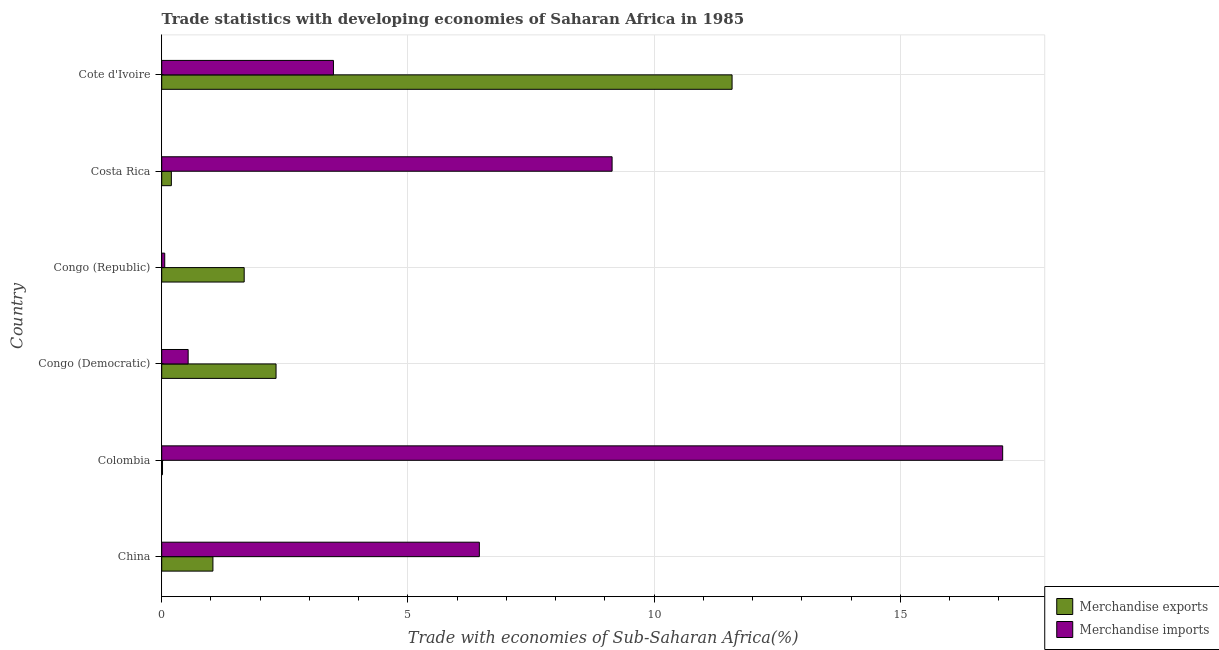What is the label of the 6th group of bars from the top?
Give a very brief answer. China. What is the merchandise imports in Cote d'Ivoire?
Offer a very short reply. 3.49. Across all countries, what is the maximum merchandise imports?
Ensure brevity in your answer.  17.08. Across all countries, what is the minimum merchandise imports?
Provide a short and direct response. 0.06. In which country was the merchandise exports maximum?
Give a very brief answer. Cote d'Ivoire. In which country was the merchandise imports minimum?
Keep it short and to the point. Congo (Republic). What is the total merchandise exports in the graph?
Your answer should be very brief. 16.83. What is the difference between the merchandise imports in China and that in Congo (Democratic)?
Your answer should be compact. 5.91. What is the difference between the merchandise imports in Colombia and the merchandise exports in Congo (Democratic)?
Ensure brevity in your answer.  14.76. What is the average merchandise exports per country?
Offer a very short reply. 2.81. What is the difference between the merchandise exports and merchandise imports in Colombia?
Your answer should be very brief. -17.06. What is the ratio of the merchandise imports in China to that in Colombia?
Your answer should be compact. 0.38. Is the merchandise exports in Congo (Democratic) less than that in Congo (Republic)?
Make the answer very short. No. What is the difference between the highest and the second highest merchandise exports?
Make the answer very short. 9.26. What is the difference between the highest and the lowest merchandise imports?
Your answer should be compact. 17.02. Is the sum of the merchandise exports in China and Congo (Republic) greater than the maximum merchandise imports across all countries?
Provide a succinct answer. No. What does the 2nd bar from the bottom in Colombia represents?
Keep it short and to the point. Merchandise imports. How many bars are there?
Your answer should be very brief. 12. Are the values on the major ticks of X-axis written in scientific E-notation?
Offer a very short reply. No. Does the graph contain any zero values?
Keep it short and to the point. No. Where does the legend appear in the graph?
Give a very brief answer. Bottom right. How are the legend labels stacked?
Offer a very short reply. Vertical. What is the title of the graph?
Make the answer very short. Trade statistics with developing economies of Saharan Africa in 1985. What is the label or title of the X-axis?
Keep it short and to the point. Trade with economies of Sub-Saharan Africa(%). What is the label or title of the Y-axis?
Make the answer very short. Country. What is the Trade with economies of Sub-Saharan Africa(%) in Merchandise exports in China?
Offer a very short reply. 1.04. What is the Trade with economies of Sub-Saharan Africa(%) of Merchandise imports in China?
Offer a very short reply. 6.45. What is the Trade with economies of Sub-Saharan Africa(%) in Merchandise exports in Colombia?
Keep it short and to the point. 0.02. What is the Trade with economies of Sub-Saharan Africa(%) of Merchandise imports in Colombia?
Offer a very short reply. 17.08. What is the Trade with economies of Sub-Saharan Africa(%) of Merchandise exports in Congo (Democratic)?
Your response must be concise. 2.32. What is the Trade with economies of Sub-Saharan Africa(%) of Merchandise imports in Congo (Democratic)?
Give a very brief answer. 0.54. What is the Trade with economies of Sub-Saharan Africa(%) of Merchandise exports in Congo (Republic)?
Ensure brevity in your answer.  1.68. What is the Trade with economies of Sub-Saharan Africa(%) of Merchandise imports in Congo (Republic)?
Provide a succinct answer. 0.06. What is the Trade with economies of Sub-Saharan Africa(%) in Merchandise exports in Costa Rica?
Provide a short and direct response. 0.2. What is the Trade with economies of Sub-Saharan Africa(%) in Merchandise imports in Costa Rica?
Keep it short and to the point. 9.15. What is the Trade with economies of Sub-Saharan Africa(%) of Merchandise exports in Cote d'Ivoire?
Provide a short and direct response. 11.58. What is the Trade with economies of Sub-Saharan Africa(%) of Merchandise imports in Cote d'Ivoire?
Offer a terse response. 3.49. Across all countries, what is the maximum Trade with economies of Sub-Saharan Africa(%) of Merchandise exports?
Offer a very short reply. 11.58. Across all countries, what is the maximum Trade with economies of Sub-Saharan Africa(%) in Merchandise imports?
Offer a very short reply. 17.08. Across all countries, what is the minimum Trade with economies of Sub-Saharan Africa(%) in Merchandise exports?
Offer a very short reply. 0.02. Across all countries, what is the minimum Trade with economies of Sub-Saharan Africa(%) in Merchandise imports?
Provide a short and direct response. 0.06. What is the total Trade with economies of Sub-Saharan Africa(%) of Merchandise exports in the graph?
Make the answer very short. 16.83. What is the total Trade with economies of Sub-Saharan Africa(%) of Merchandise imports in the graph?
Give a very brief answer. 36.76. What is the difference between the Trade with economies of Sub-Saharan Africa(%) in Merchandise exports in China and that in Colombia?
Your answer should be very brief. 1.02. What is the difference between the Trade with economies of Sub-Saharan Africa(%) in Merchandise imports in China and that in Colombia?
Offer a very short reply. -10.63. What is the difference between the Trade with economies of Sub-Saharan Africa(%) of Merchandise exports in China and that in Congo (Democratic)?
Keep it short and to the point. -1.28. What is the difference between the Trade with economies of Sub-Saharan Africa(%) of Merchandise imports in China and that in Congo (Democratic)?
Your response must be concise. 5.91. What is the difference between the Trade with economies of Sub-Saharan Africa(%) in Merchandise exports in China and that in Congo (Republic)?
Make the answer very short. -0.64. What is the difference between the Trade with economies of Sub-Saharan Africa(%) of Merchandise imports in China and that in Congo (Republic)?
Your answer should be compact. 6.39. What is the difference between the Trade with economies of Sub-Saharan Africa(%) of Merchandise exports in China and that in Costa Rica?
Your response must be concise. 0.84. What is the difference between the Trade with economies of Sub-Saharan Africa(%) of Merchandise imports in China and that in Costa Rica?
Your answer should be very brief. -2.7. What is the difference between the Trade with economies of Sub-Saharan Africa(%) in Merchandise exports in China and that in Cote d'Ivoire?
Offer a terse response. -10.54. What is the difference between the Trade with economies of Sub-Saharan Africa(%) in Merchandise imports in China and that in Cote d'Ivoire?
Your response must be concise. 2.96. What is the difference between the Trade with economies of Sub-Saharan Africa(%) in Merchandise exports in Colombia and that in Congo (Democratic)?
Your answer should be very brief. -2.31. What is the difference between the Trade with economies of Sub-Saharan Africa(%) of Merchandise imports in Colombia and that in Congo (Democratic)?
Your answer should be compact. 16.54. What is the difference between the Trade with economies of Sub-Saharan Africa(%) in Merchandise exports in Colombia and that in Congo (Republic)?
Keep it short and to the point. -1.66. What is the difference between the Trade with economies of Sub-Saharan Africa(%) in Merchandise imports in Colombia and that in Congo (Republic)?
Offer a very short reply. 17.02. What is the difference between the Trade with economies of Sub-Saharan Africa(%) in Merchandise exports in Colombia and that in Costa Rica?
Your answer should be compact. -0.18. What is the difference between the Trade with economies of Sub-Saharan Africa(%) of Merchandise imports in Colombia and that in Costa Rica?
Keep it short and to the point. 7.93. What is the difference between the Trade with economies of Sub-Saharan Africa(%) of Merchandise exports in Colombia and that in Cote d'Ivoire?
Provide a succinct answer. -11.57. What is the difference between the Trade with economies of Sub-Saharan Africa(%) in Merchandise imports in Colombia and that in Cote d'Ivoire?
Offer a terse response. 13.59. What is the difference between the Trade with economies of Sub-Saharan Africa(%) of Merchandise exports in Congo (Democratic) and that in Congo (Republic)?
Provide a succinct answer. 0.65. What is the difference between the Trade with economies of Sub-Saharan Africa(%) of Merchandise imports in Congo (Democratic) and that in Congo (Republic)?
Your answer should be very brief. 0.48. What is the difference between the Trade with economies of Sub-Saharan Africa(%) in Merchandise exports in Congo (Democratic) and that in Costa Rica?
Offer a terse response. 2.13. What is the difference between the Trade with economies of Sub-Saharan Africa(%) of Merchandise imports in Congo (Democratic) and that in Costa Rica?
Your answer should be very brief. -8.61. What is the difference between the Trade with economies of Sub-Saharan Africa(%) in Merchandise exports in Congo (Democratic) and that in Cote d'Ivoire?
Offer a terse response. -9.26. What is the difference between the Trade with economies of Sub-Saharan Africa(%) of Merchandise imports in Congo (Democratic) and that in Cote d'Ivoire?
Your answer should be very brief. -2.95. What is the difference between the Trade with economies of Sub-Saharan Africa(%) in Merchandise exports in Congo (Republic) and that in Costa Rica?
Your answer should be very brief. 1.48. What is the difference between the Trade with economies of Sub-Saharan Africa(%) in Merchandise imports in Congo (Republic) and that in Costa Rica?
Your answer should be very brief. -9.09. What is the difference between the Trade with economies of Sub-Saharan Africa(%) of Merchandise exports in Congo (Republic) and that in Cote d'Ivoire?
Your response must be concise. -9.91. What is the difference between the Trade with economies of Sub-Saharan Africa(%) of Merchandise imports in Congo (Republic) and that in Cote d'Ivoire?
Offer a terse response. -3.43. What is the difference between the Trade with economies of Sub-Saharan Africa(%) in Merchandise exports in Costa Rica and that in Cote d'Ivoire?
Offer a very short reply. -11.39. What is the difference between the Trade with economies of Sub-Saharan Africa(%) in Merchandise imports in Costa Rica and that in Cote d'Ivoire?
Your answer should be very brief. 5.66. What is the difference between the Trade with economies of Sub-Saharan Africa(%) in Merchandise exports in China and the Trade with economies of Sub-Saharan Africa(%) in Merchandise imports in Colombia?
Provide a short and direct response. -16.04. What is the difference between the Trade with economies of Sub-Saharan Africa(%) of Merchandise exports in China and the Trade with economies of Sub-Saharan Africa(%) of Merchandise imports in Congo (Democratic)?
Give a very brief answer. 0.5. What is the difference between the Trade with economies of Sub-Saharan Africa(%) in Merchandise exports in China and the Trade with economies of Sub-Saharan Africa(%) in Merchandise imports in Congo (Republic)?
Give a very brief answer. 0.98. What is the difference between the Trade with economies of Sub-Saharan Africa(%) of Merchandise exports in China and the Trade with economies of Sub-Saharan Africa(%) of Merchandise imports in Costa Rica?
Ensure brevity in your answer.  -8.11. What is the difference between the Trade with economies of Sub-Saharan Africa(%) of Merchandise exports in China and the Trade with economies of Sub-Saharan Africa(%) of Merchandise imports in Cote d'Ivoire?
Provide a short and direct response. -2.45. What is the difference between the Trade with economies of Sub-Saharan Africa(%) of Merchandise exports in Colombia and the Trade with economies of Sub-Saharan Africa(%) of Merchandise imports in Congo (Democratic)?
Your answer should be very brief. -0.52. What is the difference between the Trade with economies of Sub-Saharan Africa(%) of Merchandise exports in Colombia and the Trade with economies of Sub-Saharan Africa(%) of Merchandise imports in Congo (Republic)?
Make the answer very short. -0.04. What is the difference between the Trade with economies of Sub-Saharan Africa(%) of Merchandise exports in Colombia and the Trade with economies of Sub-Saharan Africa(%) of Merchandise imports in Costa Rica?
Your answer should be compact. -9.13. What is the difference between the Trade with economies of Sub-Saharan Africa(%) in Merchandise exports in Colombia and the Trade with economies of Sub-Saharan Africa(%) in Merchandise imports in Cote d'Ivoire?
Ensure brevity in your answer.  -3.47. What is the difference between the Trade with economies of Sub-Saharan Africa(%) in Merchandise exports in Congo (Democratic) and the Trade with economies of Sub-Saharan Africa(%) in Merchandise imports in Congo (Republic)?
Offer a very short reply. 2.26. What is the difference between the Trade with economies of Sub-Saharan Africa(%) of Merchandise exports in Congo (Democratic) and the Trade with economies of Sub-Saharan Africa(%) of Merchandise imports in Costa Rica?
Make the answer very short. -6.82. What is the difference between the Trade with economies of Sub-Saharan Africa(%) in Merchandise exports in Congo (Democratic) and the Trade with economies of Sub-Saharan Africa(%) in Merchandise imports in Cote d'Ivoire?
Ensure brevity in your answer.  -1.17. What is the difference between the Trade with economies of Sub-Saharan Africa(%) in Merchandise exports in Congo (Republic) and the Trade with economies of Sub-Saharan Africa(%) in Merchandise imports in Costa Rica?
Provide a succinct answer. -7.47. What is the difference between the Trade with economies of Sub-Saharan Africa(%) of Merchandise exports in Congo (Republic) and the Trade with economies of Sub-Saharan Africa(%) of Merchandise imports in Cote d'Ivoire?
Offer a very short reply. -1.81. What is the difference between the Trade with economies of Sub-Saharan Africa(%) in Merchandise exports in Costa Rica and the Trade with economies of Sub-Saharan Africa(%) in Merchandise imports in Cote d'Ivoire?
Your response must be concise. -3.29. What is the average Trade with economies of Sub-Saharan Africa(%) in Merchandise exports per country?
Provide a succinct answer. 2.81. What is the average Trade with economies of Sub-Saharan Africa(%) of Merchandise imports per country?
Offer a very short reply. 6.13. What is the difference between the Trade with economies of Sub-Saharan Africa(%) of Merchandise exports and Trade with economies of Sub-Saharan Africa(%) of Merchandise imports in China?
Give a very brief answer. -5.41. What is the difference between the Trade with economies of Sub-Saharan Africa(%) of Merchandise exports and Trade with economies of Sub-Saharan Africa(%) of Merchandise imports in Colombia?
Keep it short and to the point. -17.06. What is the difference between the Trade with economies of Sub-Saharan Africa(%) in Merchandise exports and Trade with economies of Sub-Saharan Africa(%) in Merchandise imports in Congo (Democratic)?
Provide a short and direct response. 1.79. What is the difference between the Trade with economies of Sub-Saharan Africa(%) of Merchandise exports and Trade with economies of Sub-Saharan Africa(%) of Merchandise imports in Congo (Republic)?
Provide a short and direct response. 1.61. What is the difference between the Trade with economies of Sub-Saharan Africa(%) in Merchandise exports and Trade with economies of Sub-Saharan Africa(%) in Merchandise imports in Costa Rica?
Provide a short and direct response. -8.95. What is the difference between the Trade with economies of Sub-Saharan Africa(%) in Merchandise exports and Trade with economies of Sub-Saharan Africa(%) in Merchandise imports in Cote d'Ivoire?
Provide a succinct answer. 8.1. What is the ratio of the Trade with economies of Sub-Saharan Africa(%) in Merchandise exports in China to that in Colombia?
Keep it short and to the point. 63.68. What is the ratio of the Trade with economies of Sub-Saharan Africa(%) of Merchandise imports in China to that in Colombia?
Your answer should be very brief. 0.38. What is the ratio of the Trade with economies of Sub-Saharan Africa(%) of Merchandise exports in China to that in Congo (Democratic)?
Your response must be concise. 0.45. What is the ratio of the Trade with economies of Sub-Saharan Africa(%) in Merchandise imports in China to that in Congo (Democratic)?
Your answer should be very brief. 12.01. What is the ratio of the Trade with economies of Sub-Saharan Africa(%) of Merchandise exports in China to that in Congo (Republic)?
Provide a short and direct response. 0.62. What is the ratio of the Trade with economies of Sub-Saharan Africa(%) of Merchandise imports in China to that in Congo (Republic)?
Ensure brevity in your answer.  105.32. What is the ratio of the Trade with economies of Sub-Saharan Africa(%) in Merchandise exports in China to that in Costa Rica?
Give a very brief answer. 5.31. What is the ratio of the Trade with economies of Sub-Saharan Africa(%) in Merchandise imports in China to that in Costa Rica?
Provide a short and direct response. 0.71. What is the ratio of the Trade with economies of Sub-Saharan Africa(%) of Merchandise exports in China to that in Cote d'Ivoire?
Your response must be concise. 0.09. What is the ratio of the Trade with economies of Sub-Saharan Africa(%) of Merchandise imports in China to that in Cote d'Ivoire?
Your answer should be very brief. 1.85. What is the ratio of the Trade with economies of Sub-Saharan Africa(%) in Merchandise exports in Colombia to that in Congo (Democratic)?
Your answer should be very brief. 0.01. What is the ratio of the Trade with economies of Sub-Saharan Africa(%) in Merchandise imports in Colombia to that in Congo (Democratic)?
Keep it short and to the point. 31.81. What is the ratio of the Trade with economies of Sub-Saharan Africa(%) of Merchandise exports in Colombia to that in Congo (Republic)?
Offer a very short reply. 0.01. What is the ratio of the Trade with economies of Sub-Saharan Africa(%) in Merchandise imports in Colombia to that in Congo (Republic)?
Your response must be concise. 278.83. What is the ratio of the Trade with economies of Sub-Saharan Africa(%) in Merchandise exports in Colombia to that in Costa Rica?
Keep it short and to the point. 0.08. What is the ratio of the Trade with economies of Sub-Saharan Africa(%) of Merchandise imports in Colombia to that in Costa Rica?
Offer a very short reply. 1.87. What is the ratio of the Trade with economies of Sub-Saharan Africa(%) in Merchandise exports in Colombia to that in Cote d'Ivoire?
Offer a very short reply. 0. What is the ratio of the Trade with economies of Sub-Saharan Africa(%) of Merchandise imports in Colombia to that in Cote d'Ivoire?
Your response must be concise. 4.9. What is the ratio of the Trade with economies of Sub-Saharan Africa(%) in Merchandise exports in Congo (Democratic) to that in Congo (Republic)?
Your answer should be very brief. 1.39. What is the ratio of the Trade with economies of Sub-Saharan Africa(%) of Merchandise imports in Congo (Democratic) to that in Congo (Republic)?
Your answer should be very brief. 8.77. What is the ratio of the Trade with economies of Sub-Saharan Africa(%) of Merchandise exports in Congo (Democratic) to that in Costa Rica?
Your response must be concise. 11.86. What is the ratio of the Trade with economies of Sub-Saharan Africa(%) in Merchandise imports in Congo (Democratic) to that in Costa Rica?
Your answer should be compact. 0.06. What is the ratio of the Trade with economies of Sub-Saharan Africa(%) of Merchandise exports in Congo (Democratic) to that in Cote d'Ivoire?
Keep it short and to the point. 0.2. What is the ratio of the Trade with economies of Sub-Saharan Africa(%) of Merchandise imports in Congo (Democratic) to that in Cote d'Ivoire?
Ensure brevity in your answer.  0.15. What is the ratio of the Trade with economies of Sub-Saharan Africa(%) in Merchandise exports in Congo (Republic) to that in Costa Rica?
Your answer should be compact. 8.55. What is the ratio of the Trade with economies of Sub-Saharan Africa(%) in Merchandise imports in Congo (Republic) to that in Costa Rica?
Provide a short and direct response. 0.01. What is the ratio of the Trade with economies of Sub-Saharan Africa(%) of Merchandise exports in Congo (Republic) to that in Cote d'Ivoire?
Your response must be concise. 0.14. What is the ratio of the Trade with economies of Sub-Saharan Africa(%) of Merchandise imports in Congo (Republic) to that in Cote d'Ivoire?
Offer a terse response. 0.02. What is the ratio of the Trade with economies of Sub-Saharan Africa(%) of Merchandise exports in Costa Rica to that in Cote d'Ivoire?
Provide a short and direct response. 0.02. What is the ratio of the Trade with economies of Sub-Saharan Africa(%) of Merchandise imports in Costa Rica to that in Cote d'Ivoire?
Give a very brief answer. 2.62. What is the difference between the highest and the second highest Trade with economies of Sub-Saharan Africa(%) in Merchandise exports?
Keep it short and to the point. 9.26. What is the difference between the highest and the second highest Trade with economies of Sub-Saharan Africa(%) of Merchandise imports?
Your response must be concise. 7.93. What is the difference between the highest and the lowest Trade with economies of Sub-Saharan Africa(%) in Merchandise exports?
Your response must be concise. 11.57. What is the difference between the highest and the lowest Trade with economies of Sub-Saharan Africa(%) of Merchandise imports?
Your answer should be very brief. 17.02. 